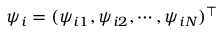Convert formula to latex. <formula><loc_0><loc_0><loc_500><loc_500>\psi _ { i } = ( \psi _ { i 1 } , \psi _ { i 2 } , \cdots , \psi _ { i N } ) ^ { \top }</formula> 